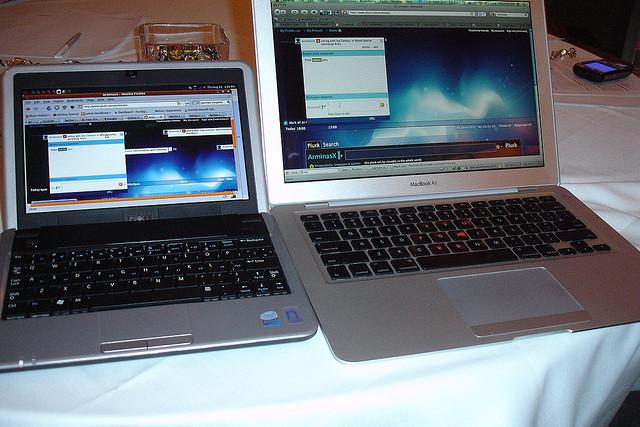What device is in the upper right?
Be succinct. Phone. What picture is in the far left screen?
Concise answer only. Window. What material is the surface of the table comprised of?
Quick response, please. Cloth. Is software being installed?
Answer briefly. Yes. What is the wallpaper?
Give a very brief answer. Lightning. Which computer is fancier?
Be succinct. One on right. How many windows are open on the computer screen?
Short answer required. 2. Is there a cat?
Give a very brief answer. No. 